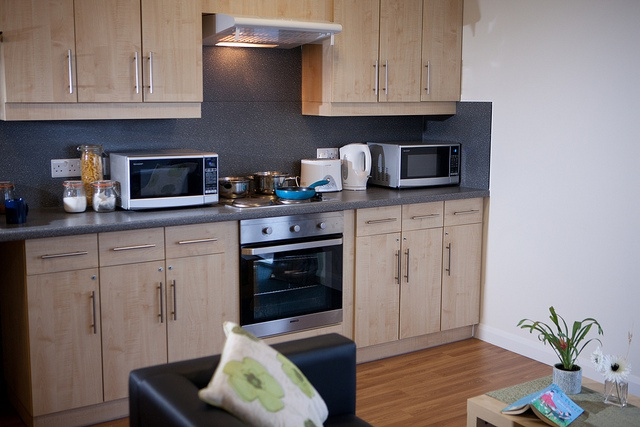Describe the objects in this image and their specific colors. I can see oven in gray, black, and darkgray tones, couch in gray, black, and navy tones, microwave in gray, black, and lavender tones, microwave in gray, black, and darkgray tones, and potted plant in gray, lightgray, and darkgray tones in this image. 